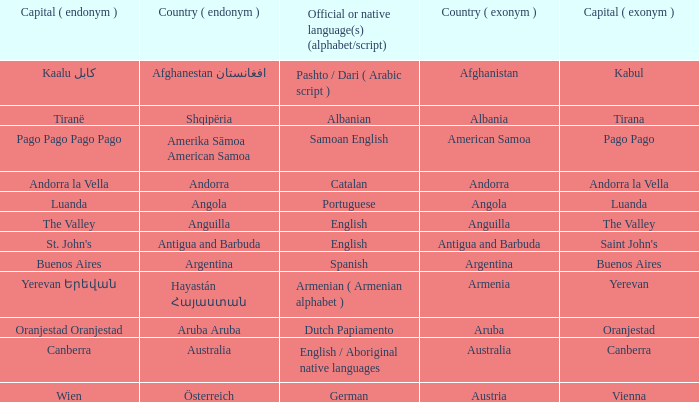How many capital cities does Australia have? 1.0. 